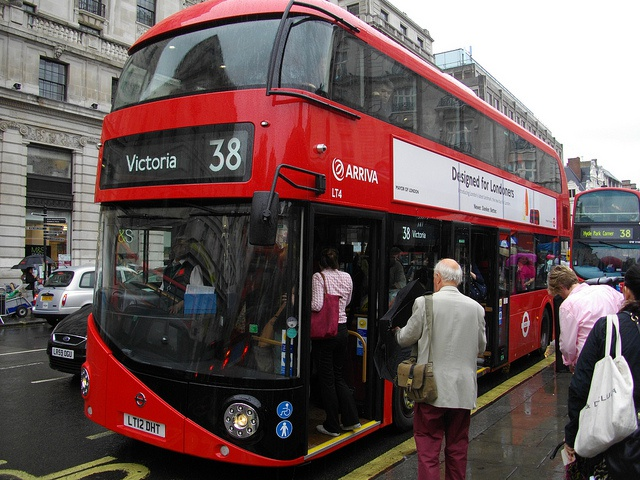Describe the objects in this image and their specific colors. I can see bus in gray, black, and brown tones, people in gray, darkgray, black, and maroon tones, bus in gray and black tones, people in gray, black, maroon, and darkgray tones, and handbag in gray, lightgray, darkgray, and black tones in this image. 